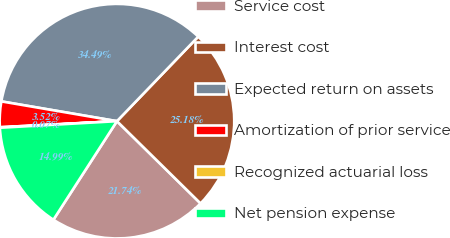Convert chart. <chart><loc_0><loc_0><loc_500><loc_500><pie_chart><fcel>Service cost<fcel>Interest cost<fcel>Expected return on assets<fcel>Amortization of prior service<fcel>Recognized actuarial loss<fcel>Net pension expense<nl><fcel>21.74%<fcel>25.18%<fcel>34.49%<fcel>3.52%<fcel>0.07%<fcel>14.99%<nl></chart> 